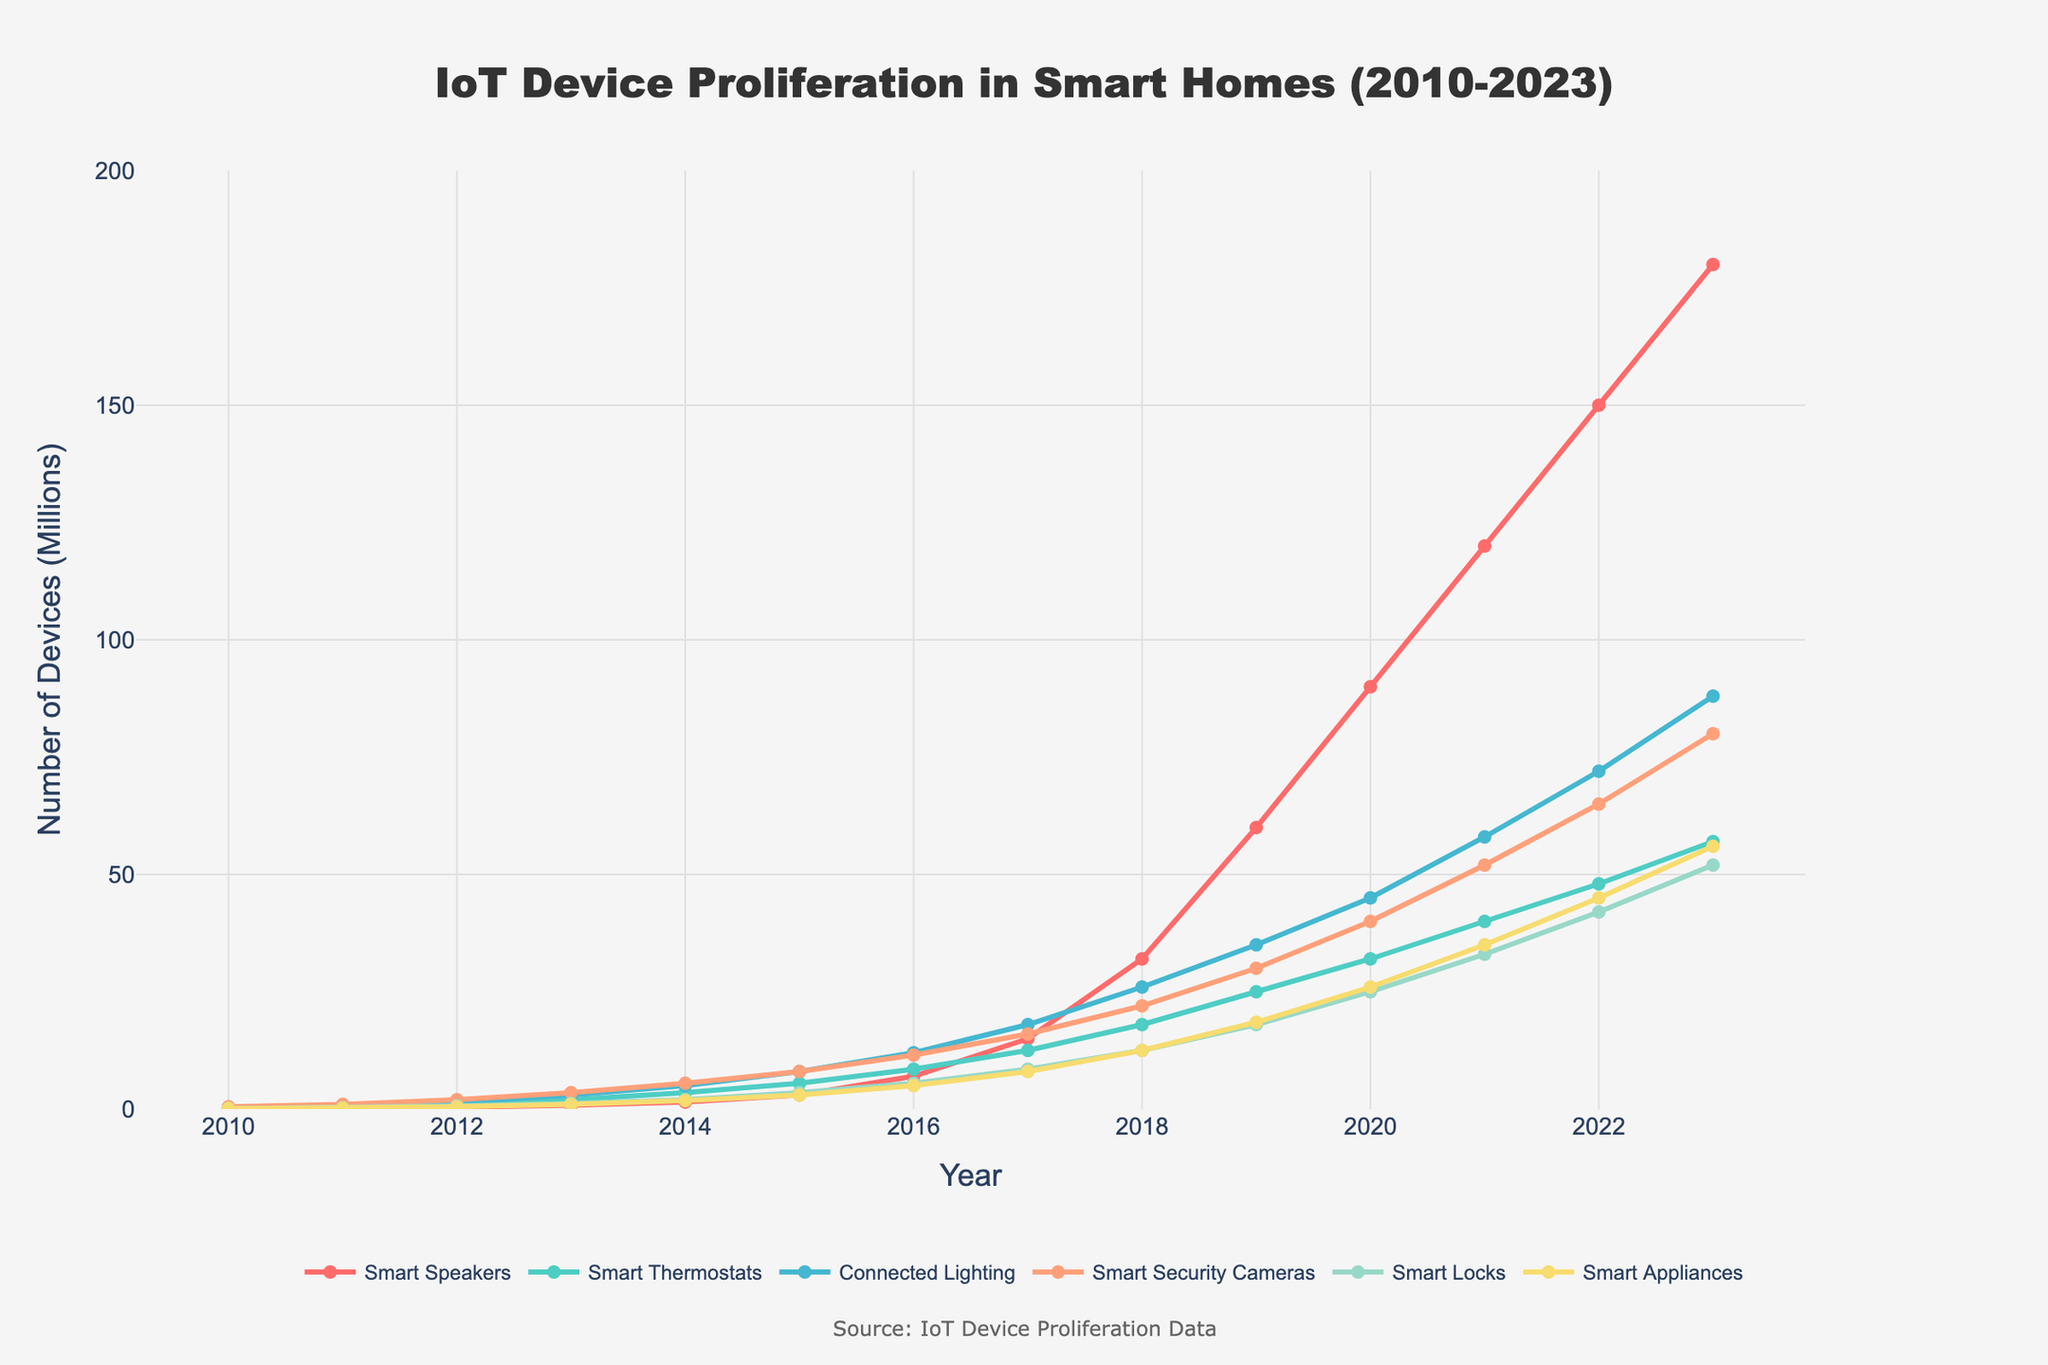What is the total number of Smart Speakers in 2015 and 2018 combined? The number of Smart Speakers in 2015 is 3.0 million and in 2018 is 32.0 million. Adding them together: 3.0 + 32.0 = 35.0 million.
Answer: 35.0 million In which year did Smart Security Cameras surpass 50 million units? The plot shows that Smart Security Cameras surpassed 50 million units in 2021, where the value reaches 52.0 million.
Answer: 2021 How did the proliferation of Smart Thermostats and Smart Appliances differ between 2012 and 2013? In 2012, Smart Thermostats were at 1.0 million and increased to 2.0 million in 2013 (difference: 1.0 million). Smart Appliances were at 0.5 million in 2012 and increased to 1.0 million in 2013 (difference: 0.5 million). Thus, Smart Thermostats grew by 1.0 million, double the growth of Smart Appliances.
Answer: Smart Thermostats grew by 1.0 million, which is double the 0.5 million growth of Smart Appliances Which category had the highest increase in number from 2014 to 2017? By comparing the values in 2014 and 2017 for each category, we observe the changes: 
- Smart Speakers: 1.5 to 15.0 (13.5 million)
- Smart Thermostats: 3.5 to 12.5 (9.0 million)
- Connected Lighting: 5.0 to 18.0 (13.0 million)
- Smart Security Cameras: 5.5 to 16.0 (10.5 million)
- Smart Locks: 2.0 to 8.5 (6.5 million)
- Smart Appliances: 1.8 to 8.0 (6.2 million)
Smart Speakers show the highest increase of 13.5 million units.
Answer: Smart Speakers with an increase of 13.5 million What was the average number of Connected Lighting devices over the years 2019, 2020, and 2021? The values for Connected Lighting are 35.0 million in 2019, 45.0 million in 2020, and 58.0 million in 2021. The average is calculated as (35.0 + 45.0 + 58.0) / 3 = 138.0 / 3 = 46.0 million.
Answer: 46.0 million Compare the number of Smart Locks and Smart Appliances in the year 2022. Which category had more units? In 2022, the number of Smart Locks is 42.0 million, while Smart Appliances are at 45.0 million. Smart Appliances had more units.
Answer: Smart Appliances What was the percentage growth of Smart Speakers from 2020 to 2021? In 2020, Smart Speakers were at 90.0 million and in 2021 they were at 120.0 million. The growth is (120.0 - 90.0) / 90.0 * 100% = 30.0 / 90.0 * 100% = 33.33%.
Answer: 33.33% Which device category showed steady growth without any decline from 2010 to 2023? By observing the lines on the plot, all device categories—Smart Speakers, Smart Thermostats, Connected Lighting, Smart Security Cameras, Smart Locks, and Smart Appliances—show a steady increase without any decline throughout the period from 2010 to 2023.
Answer: All categories showed steady growth What is the sum of all device categories in 2023? Adding all the device counts in 2023: Smart Speakers (180.0), Smart Thermostats (57.0), Connected Lighting (88.0), Smart Security Cameras (80.0), Smart Locks (52.0), and Smart Appliances (56.0). Sum is: 180.0 + 57.0 + 88.0 + 80.0 + 52.0 + 56.0 = 513.0 million.
Answer: 513.0 million 